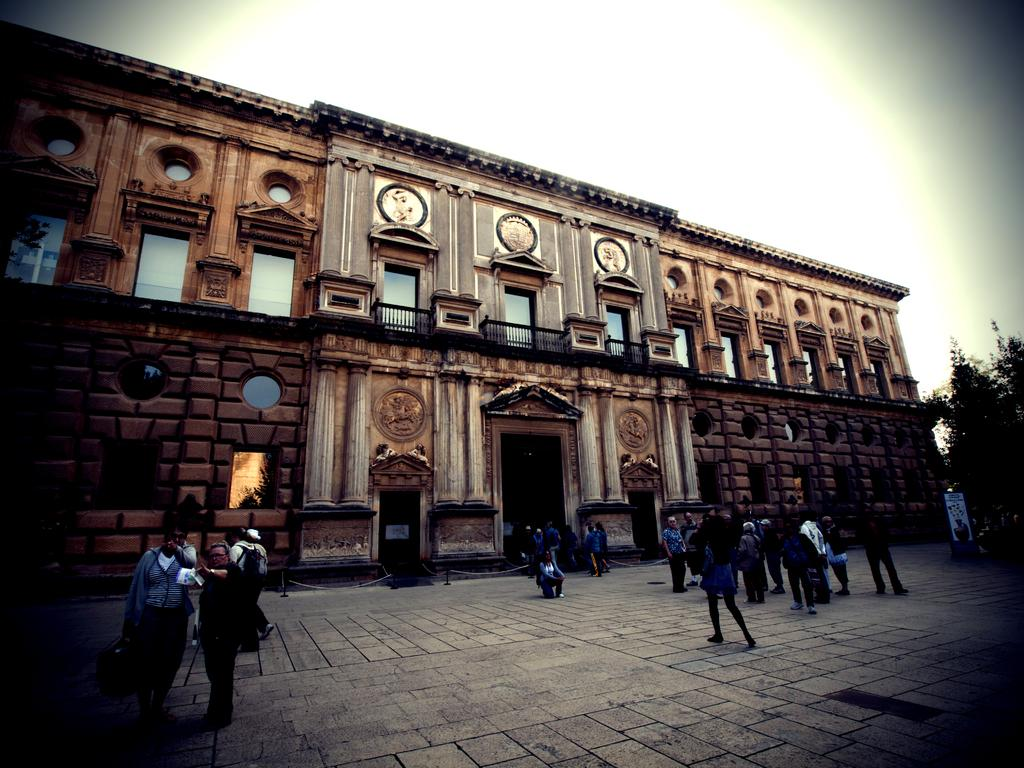What is the main structure in the image? There is a building in the image. Are there any people present in the image? Yes, there are people in front of the building. What type of vegetation can be seen in the image? There is a tree in the right corner of the image. What type of butter is being used by the people in the image? There is no butter present in the image. What kind of boundary is depicted in the image? The image does not show any boundaries. 